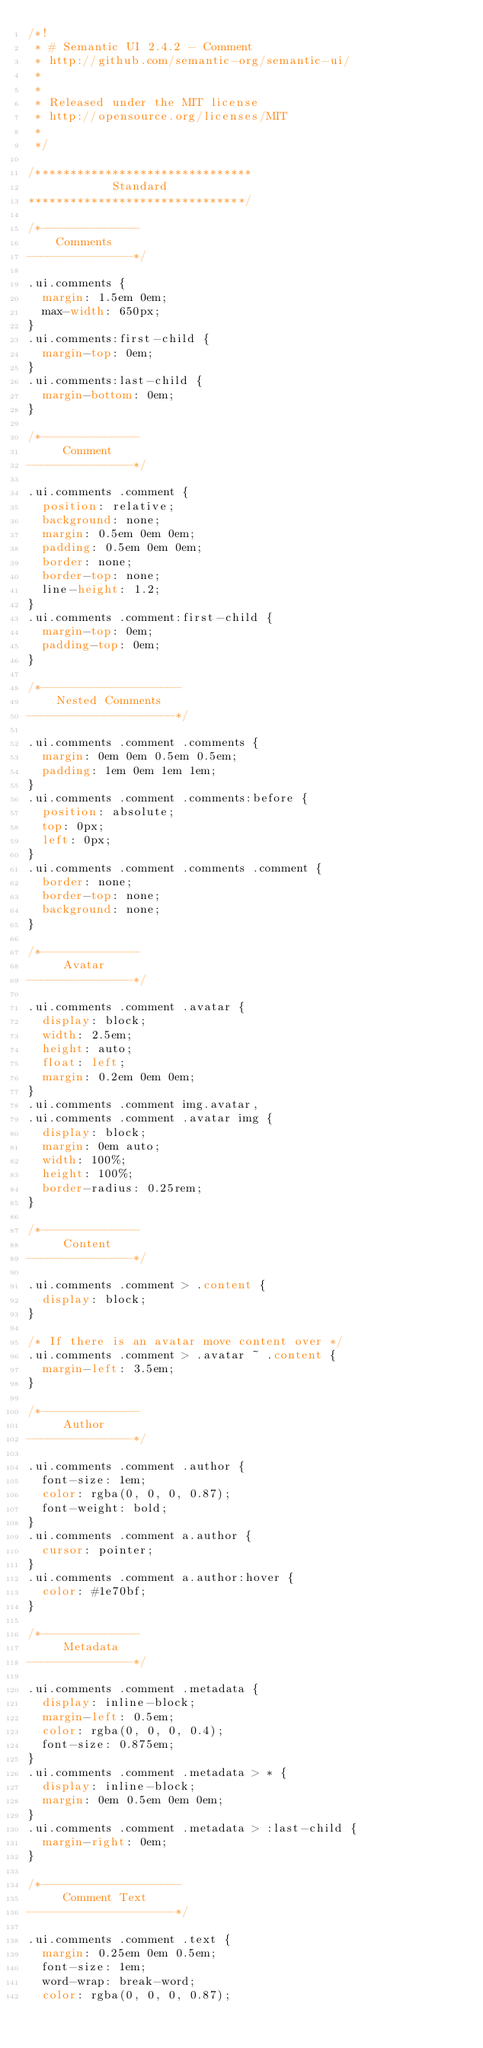<code> <loc_0><loc_0><loc_500><loc_500><_CSS_>/*!
 * # Semantic UI 2.4.2 - Comment
 * http://github.com/semantic-org/semantic-ui/
 *
 *
 * Released under the MIT license
 * http://opensource.org/licenses/MIT
 *
 */

/*******************************
            Standard
*******************************/

/*--------------
    Comments
---------------*/

.ui.comments {
  margin: 1.5em 0em;
  max-width: 650px;
}
.ui.comments:first-child {
  margin-top: 0em;
}
.ui.comments:last-child {
  margin-bottom: 0em;
}

/*--------------
     Comment
---------------*/

.ui.comments .comment {
  position: relative;
  background: none;
  margin: 0.5em 0em 0em;
  padding: 0.5em 0em 0em;
  border: none;
  border-top: none;
  line-height: 1.2;
}
.ui.comments .comment:first-child {
  margin-top: 0em;
  padding-top: 0em;
}

/*--------------------
    Nested Comments
---------------------*/

.ui.comments .comment .comments {
  margin: 0em 0em 0.5em 0.5em;
  padding: 1em 0em 1em 1em;
}
.ui.comments .comment .comments:before {
  position: absolute;
  top: 0px;
  left: 0px;
}
.ui.comments .comment .comments .comment {
  border: none;
  border-top: none;
  background: none;
}

/*--------------
     Avatar
---------------*/

.ui.comments .comment .avatar {
  display: block;
  width: 2.5em;
  height: auto;
  float: left;
  margin: 0.2em 0em 0em;
}
.ui.comments .comment img.avatar,
.ui.comments .comment .avatar img {
  display: block;
  margin: 0em auto;
  width: 100%;
  height: 100%;
  border-radius: 0.25rem;
}

/*--------------
     Content
---------------*/

.ui.comments .comment > .content {
  display: block;
}

/* If there is an avatar move content over */
.ui.comments .comment > .avatar ~ .content {
  margin-left: 3.5em;
}

/*--------------
     Author
---------------*/

.ui.comments .comment .author {
  font-size: 1em;
  color: rgba(0, 0, 0, 0.87);
  font-weight: bold;
}
.ui.comments .comment a.author {
  cursor: pointer;
}
.ui.comments .comment a.author:hover {
  color: #1e70bf;
}

/*--------------
     Metadata
---------------*/

.ui.comments .comment .metadata {
  display: inline-block;
  margin-left: 0.5em;
  color: rgba(0, 0, 0, 0.4);
  font-size: 0.875em;
}
.ui.comments .comment .metadata > * {
  display: inline-block;
  margin: 0em 0.5em 0em 0em;
}
.ui.comments .comment .metadata > :last-child {
  margin-right: 0em;
}

/*--------------------
     Comment Text
---------------------*/

.ui.comments .comment .text {
  margin: 0.25em 0em 0.5em;
  font-size: 1em;
  word-wrap: break-word;
  color: rgba(0, 0, 0, 0.87);</code> 